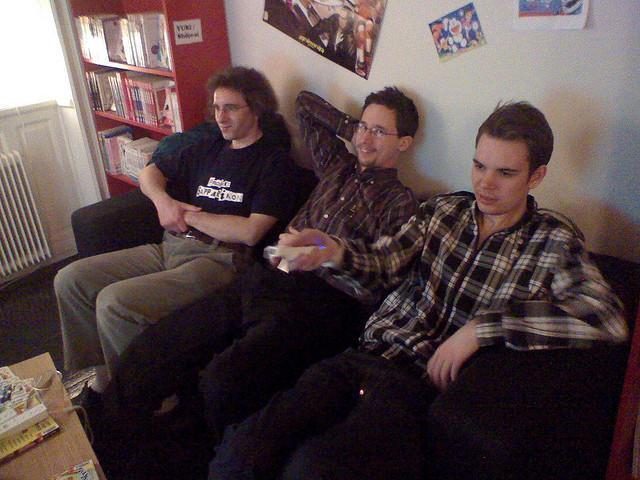What are these people engaging in?
Answer the question by selecting the correct answer among the 4 following choices.
Options: Singing karaoke, watching movie, reading books, video game. Video game. 